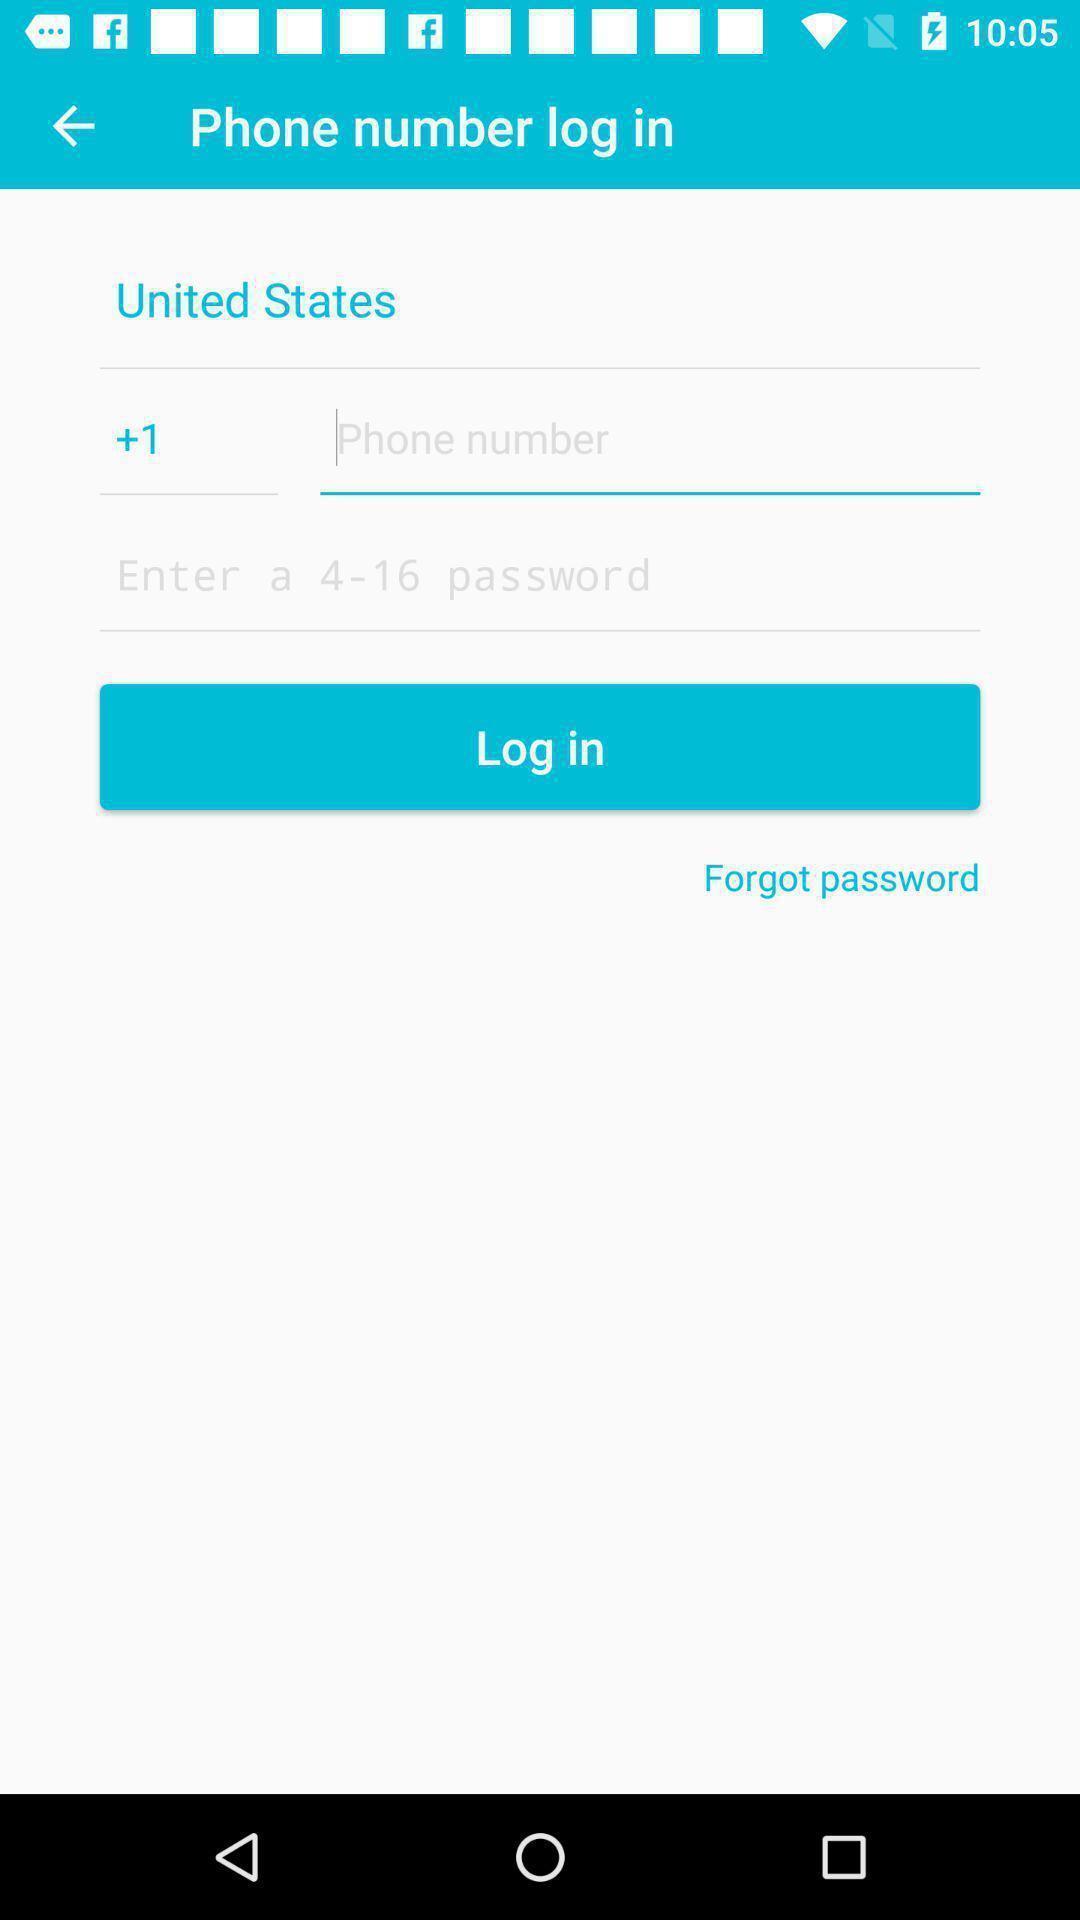Provide a description of this screenshot. Page showing a input box to add phone number. 